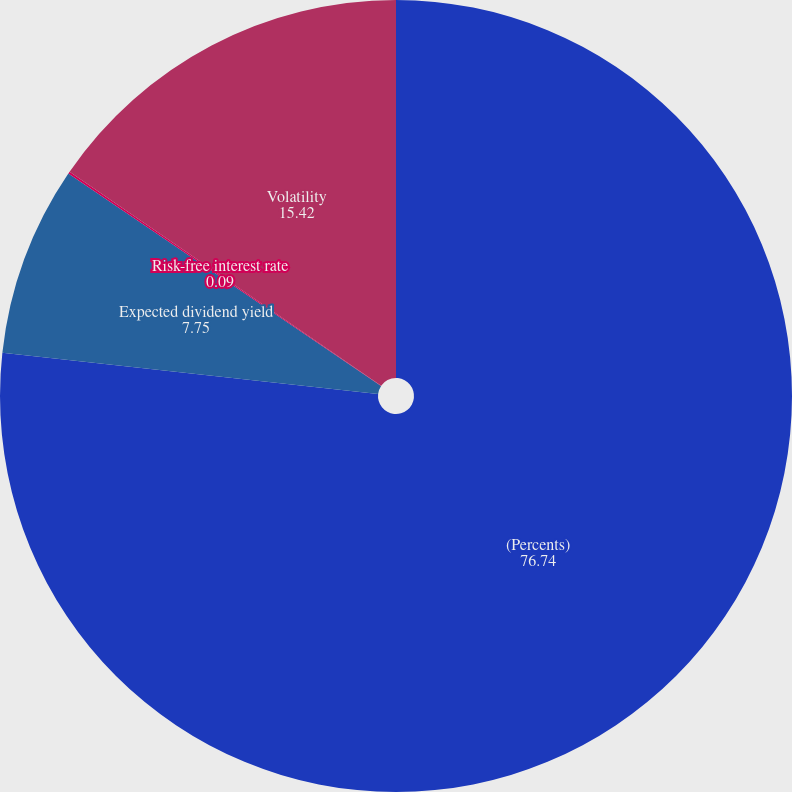<chart> <loc_0><loc_0><loc_500><loc_500><pie_chart><fcel>(Percents)<fcel>Expected dividend yield<fcel>Risk-free interest rate<fcel>Volatility<nl><fcel>76.74%<fcel>7.75%<fcel>0.09%<fcel>15.42%<nl></chart> 